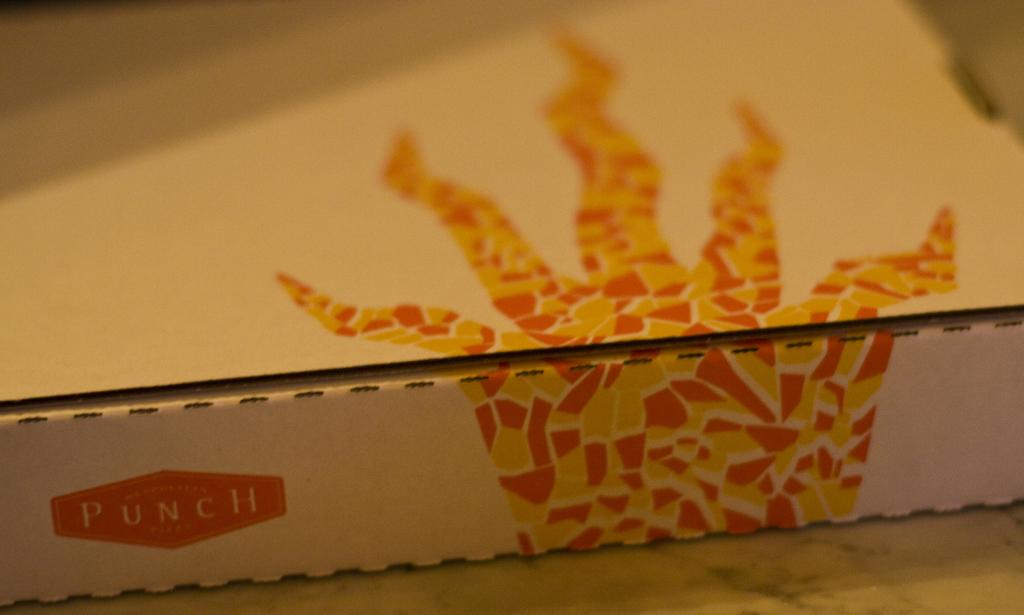What brand is on the box?
Provide a succinct answer. Punch. What kind of restaurant uses this box?
Provide a succinct answer. Punch. 